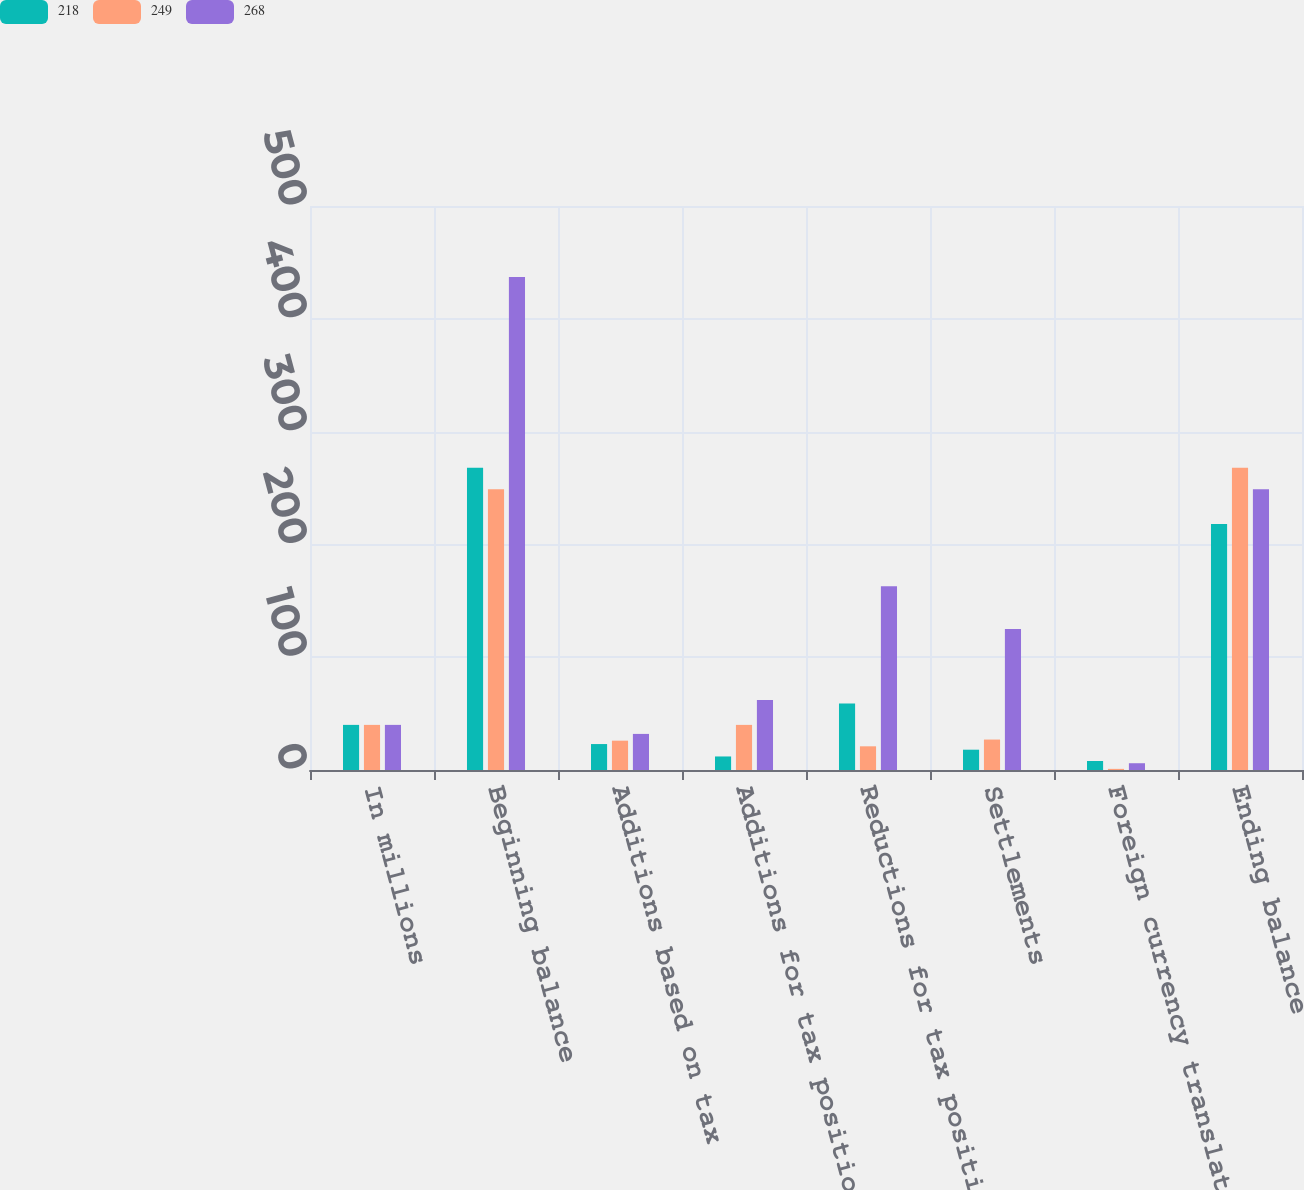<chart> <loc_0><loc_0><loc_500><loc_500><stacked_bar_chart><ecel><fcel>In millions<fcel>Beginning balance<fcel>Additions based on tax<fcel>Additions for tax positions of<fcel>Reductions for tax positions<fcel>Settlements<fcel>Foreign currency translation<fcel>Ending balance<nl><fcel>218<fcel>40<fcel>268<fcel>23<fcel>12<fcel>59<fcel>18<fcel>8<fcel>218<nl><fcel>249<fcel>40<fcel>249<fcel>26<fcel>40<fcel>21<fcel>27<fcel>1<fcel>268<nl><fcel>268<fcel>40<fcel>437<fcel>32<fcel>62<fcel>163<fcel>125<fcel>6<fcel>249<nl></chart> 